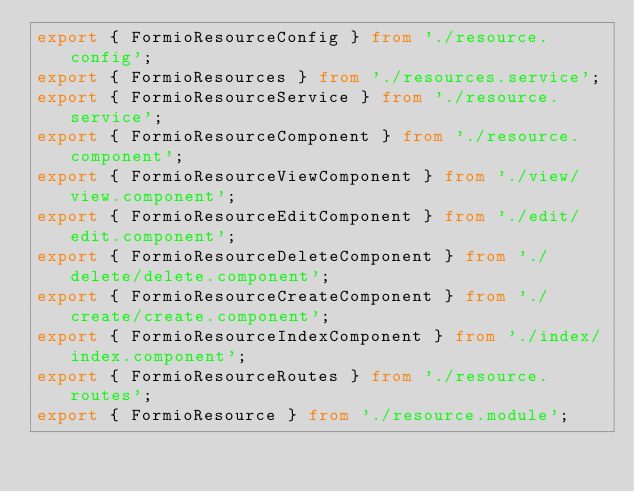Convert code to text. <code><loc_0><loc_0><loc_500><loc_500><_TypeScript_>export { FormioResourceConfig } from './resource.config';
export { FormioResources } from './resources.service';
export { FormioResourceService } from './resource.service';
export { FormioResourceComponent } from './resource.component';
export { FormioResourceViewComponent } from './view/view.component';
export { FormioResourceEditComponent } from './edit/edit.component';
export { FormioResourceDeleteComponent } from './delete/delete.component';
export { FormioResourceCreateComponent } from './create/create.component';
export { FormioResourceIndexComponent } from './index/index.component';
export { FormioResourceRoutes } from './resource.routes';
export { FormioResource } from './resource.module';
</code> 